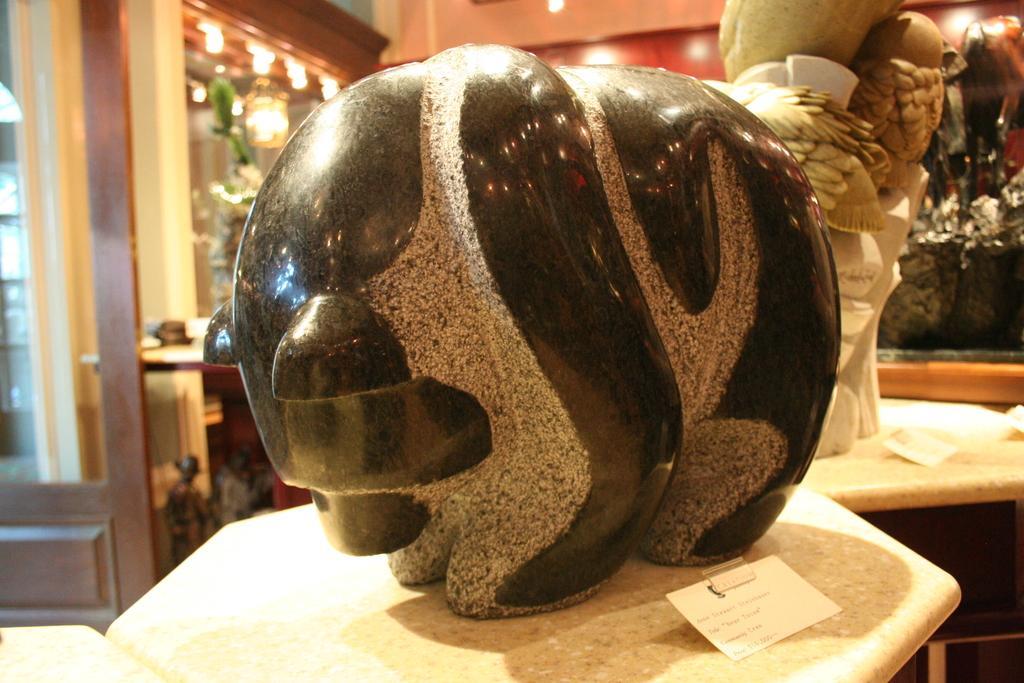Please provide a concise description of this image. In this picture we can see some objects are placed on the tables, behind we can see some lights. 